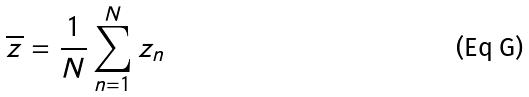<formula> <loc_0><loc_0><loc_500><loc_500>\overline { z } = \frac { 1 } { N } \sum _ { n = 1 } ^ { N } z _ { n }</formula> 